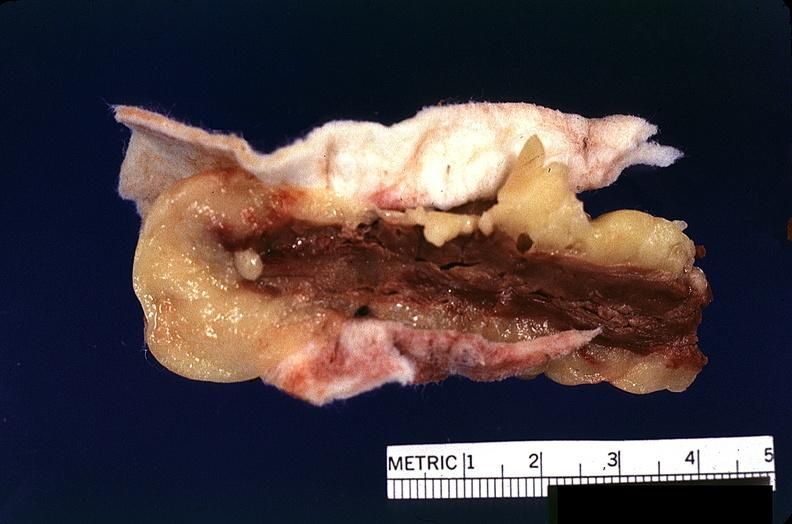what does this image show?
Answer the question using a single word or phrase. Heart 